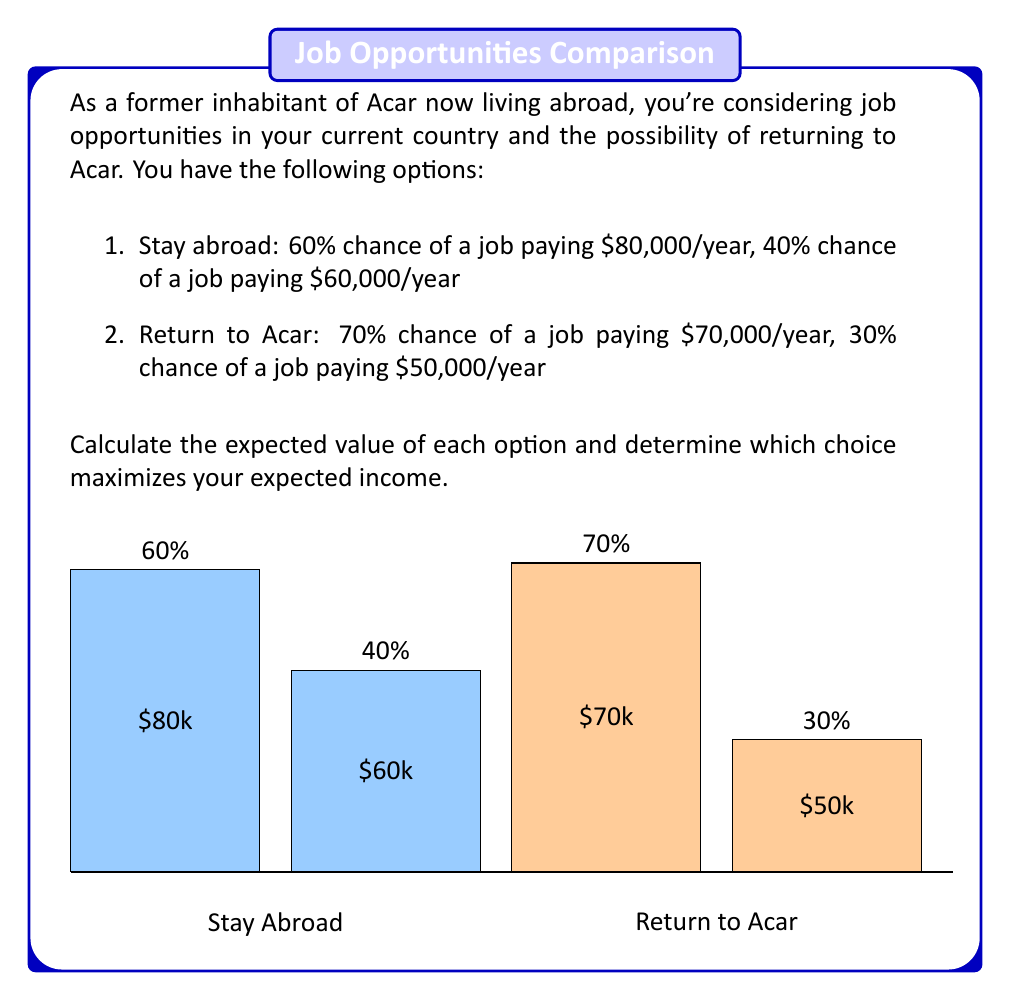Help me with this question. To solve this problem, we need to calculate the expected value of each option using the formula:

$$ E(X) = \sum_{i=1}^{n} p_i \cdot x_i $$

Where $p_i$ is the probability of each outcome and $x_i$ is the value of each outcome.

1. Expected value of staying abroad:

$$ E(\text{Stay}) = 0.60 \cdot \$80,000 + 0.40 \cdot \$60,000 $$
$$ E(\text{Stay}) = \$48,000 + \$24,000 = \$72,000 $$

2. Expected value of returning to Acar:

$$ E(\text{Return}) = 0.70 \cdot \$70,000 + 0.30 \cdot \$50,000 $$
$$ E(\text{Return}) = \$49,000 + \$15,000 = \$64,000 $$

Comparing the two expected values:

$$ E(\text{Stay}) = \$72,000 > E(\text{Return}) = \$64,000 $$

The expected value of staying abroad is higher by $\$8,000.
Answer: Stay abroad; $\$72,000 > \$64,000$ 